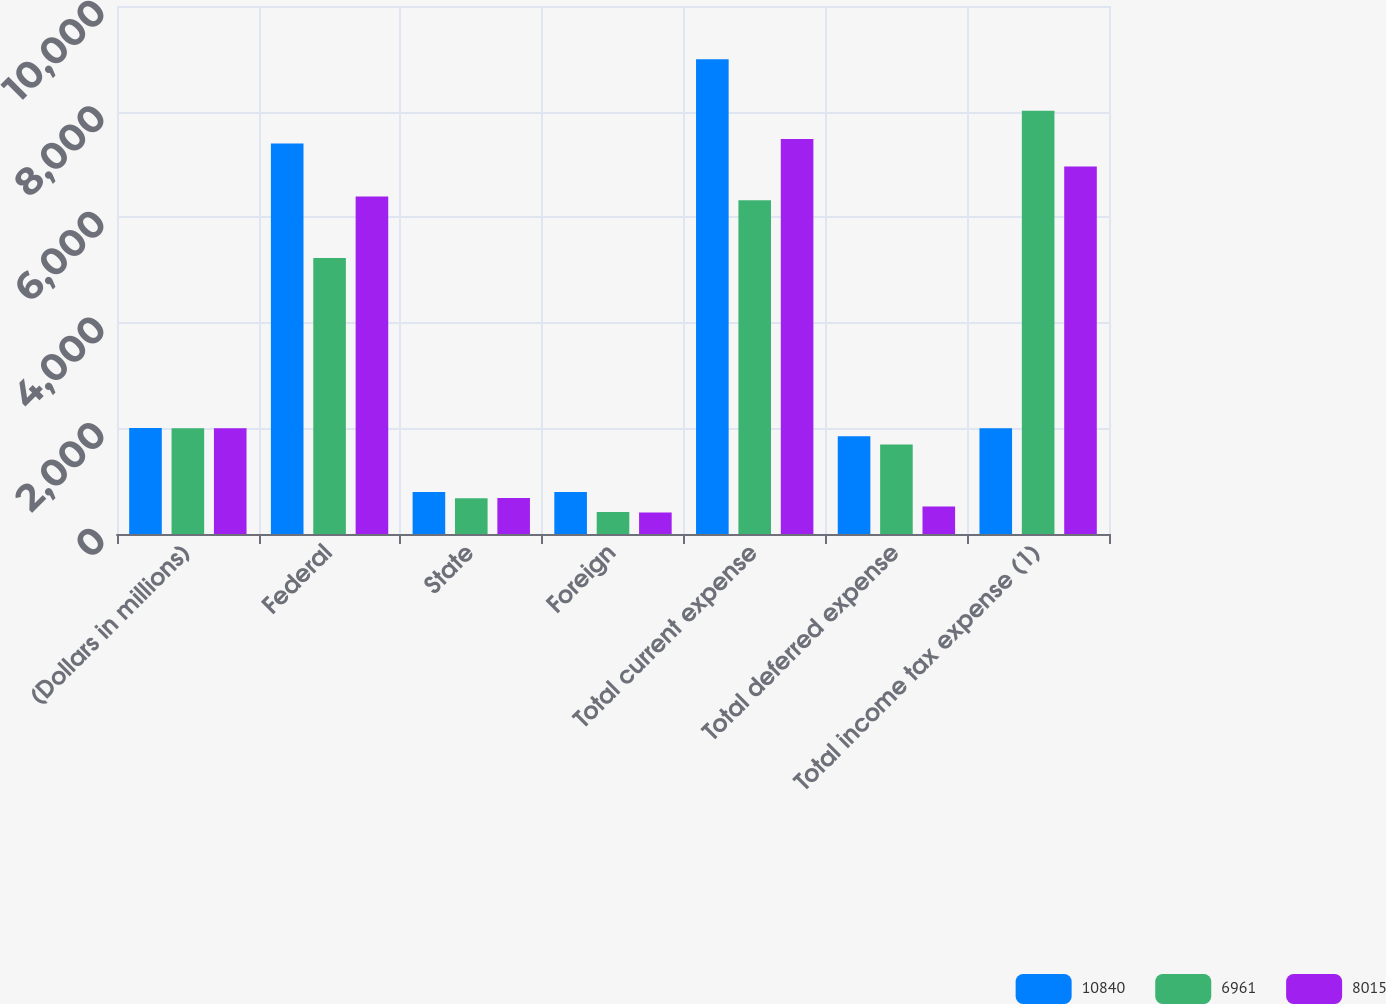Convert chart to OTSL. <chart><loc_0><loc_0><loc_500><loc_500><stacked_bar_chart><ecel><fcel>(Dollars in millions)<fcel>Federal<fcel>State<fcel>Foreign<fcel>Total current expense<fcel>Total deferred expense<fcel>Total income tax expense (1)<nl><fcel>10840<fcel>2006<fcel>7398<fcel>796<fcel>796<fcel>8990<fcel>1850<fcel>2004.5<nl><fcel>6961<fcel>2005<fcel>5229<fcel>676<fcel>415<fcel>6320<fcel>1695<fcel>8015<nl><fcel>8015<fcel>2004<fcel>6392<fcel>683<fcel>405<fcel>7480<fcel>519<fcel>6961<nl></chart> 